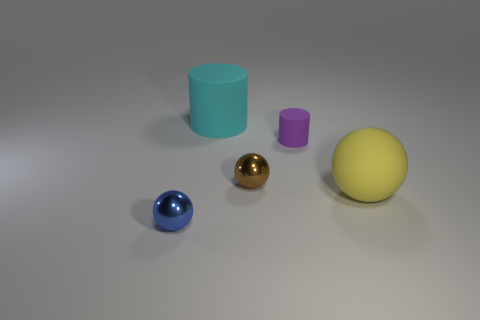Subtract all small balls. How many balls are left? 1 Subtract all spheres. How many objects are left? 2 Add 2 large gray matte cylinders. How many objects exist? 7 Add 4 tiny brown things. How many tiny brown things exist? 5 Subtract all yellow spheres. How many spheres are left? 2 Subtract 0 green spheres. How many objects are left? 5 Subtract 1 spheres. How many spheres are left? 2 Subtract all purple cylinders. Subtract all red blocks. How many cylinders are left? 1 Subtract all red blocks. How many yellow spheres are left? 1 Subtract all tiny green rubber cylinders. Subtract all spheres. How many objects are left? 2 